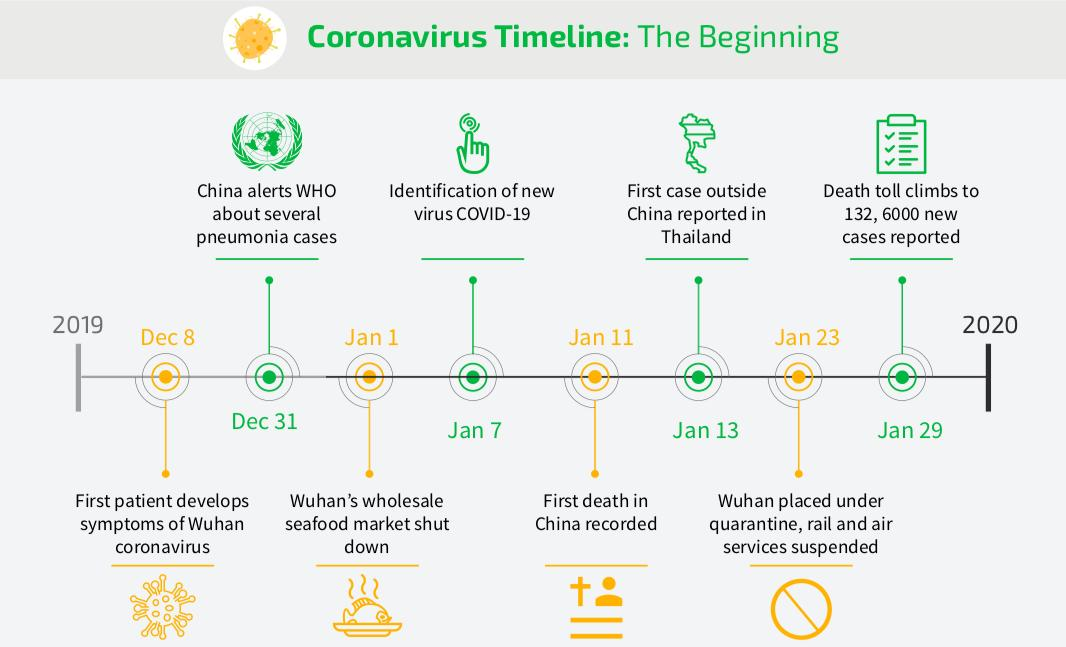Highlight a few significant elements in this photo. The first reported COVID-19 death in China occurred on January 11, 2020. On January 7th, 2020, COVID-19 was identified. The first case of COVID-19 was reported outside of China on January 13. 